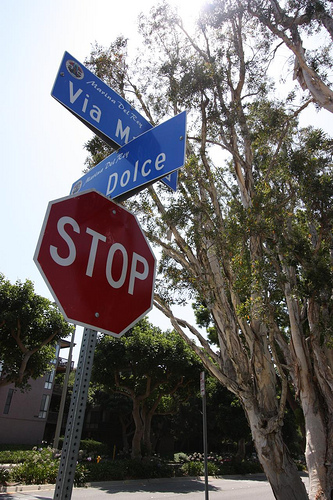Identify the text displayed in this image. via marina ray Dolce STOP ray 